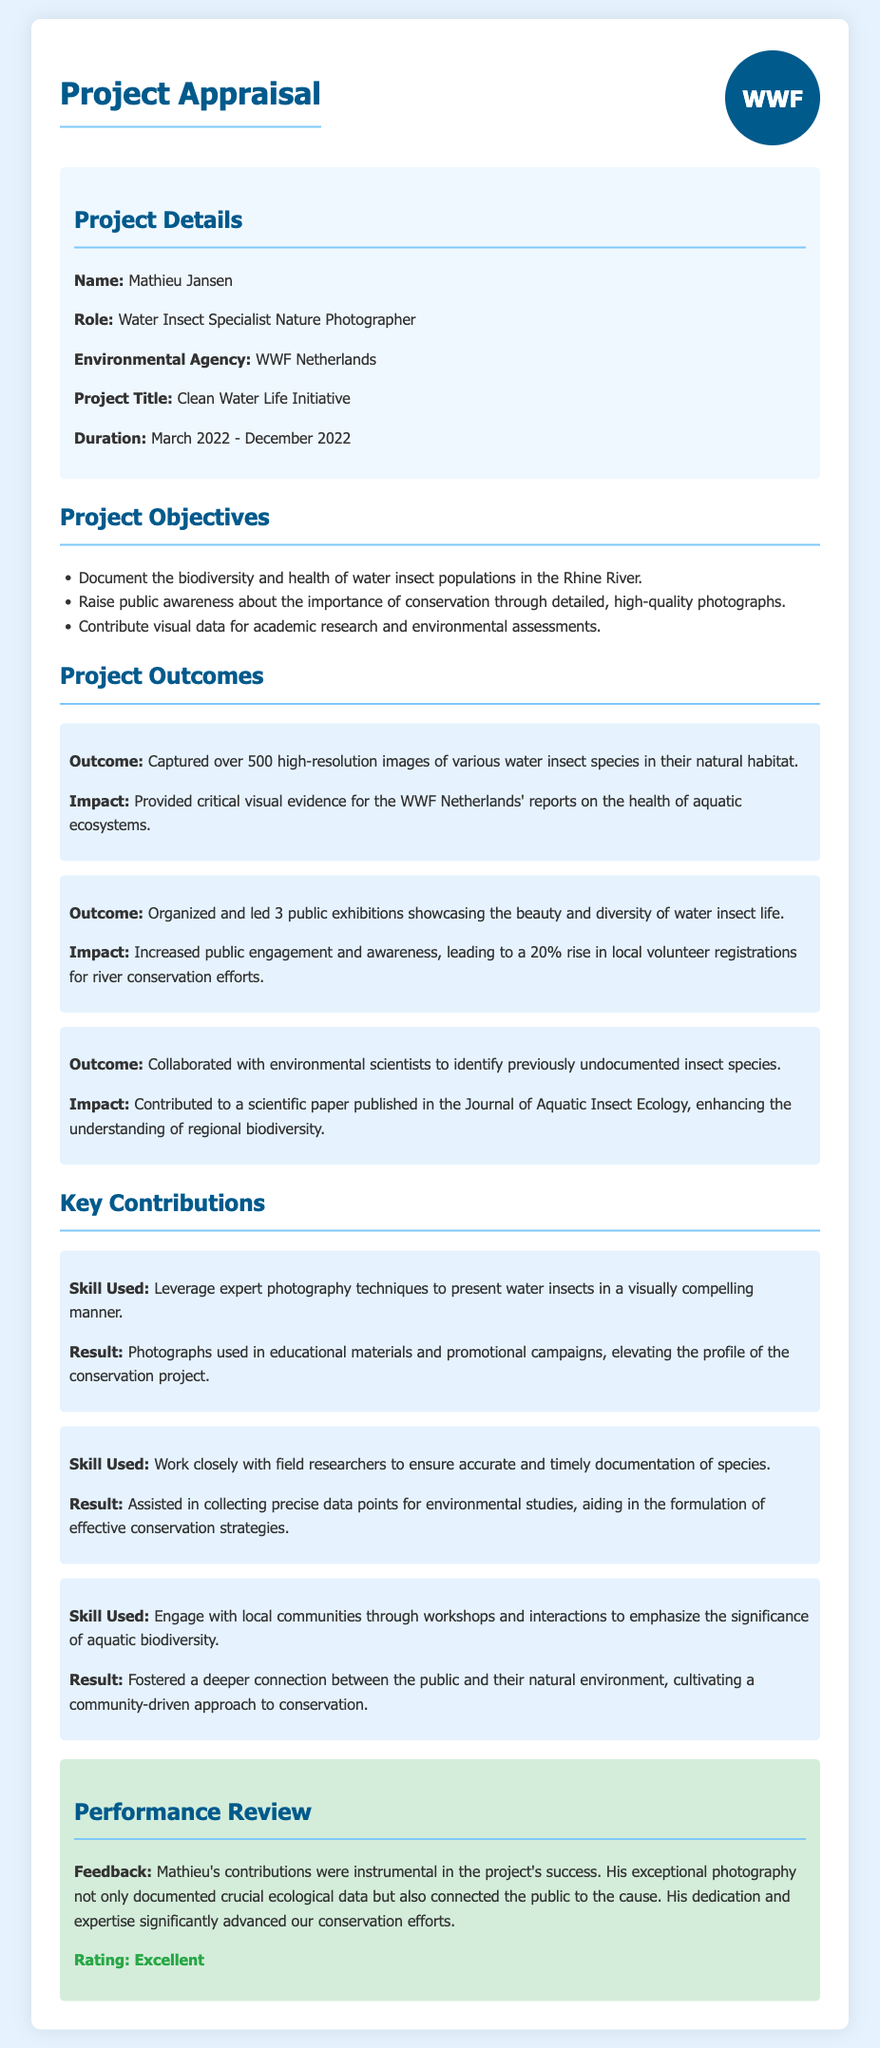What is the name of the project? The project name is stated clearly in the project details section.
Answer: Clean Water Life Initiative Who is the Water Insect Specialist Nature Photographer? The person's role is mentioned in the project details section.
Answer: Mathieu Jansen What is the duration of the project? The start and end dates can be found in the project details.
Answer: March 2022 - December 2022 How many public exhibitions were organized? The number of public exhibitions is provided in the outcomes section.
Answer: 3 What significant impact resulted from public exhibitions? The outcomes section mentions the impact on local volunteer registrations.
Answer: 20% rise Which journal published the scientific paper? The journal name is specified in the outcomes related to collaboration.
Answer: Journal of Aquatic Insect Ecology What skill did Mathieu use to document species accurately? The key contributions section refers to a specific skill used for documentation.
Answer: Work closely with field researchers What was the overall performance rating given to Mathieu? The performance review section includes the rating.
Answer: Excellent 